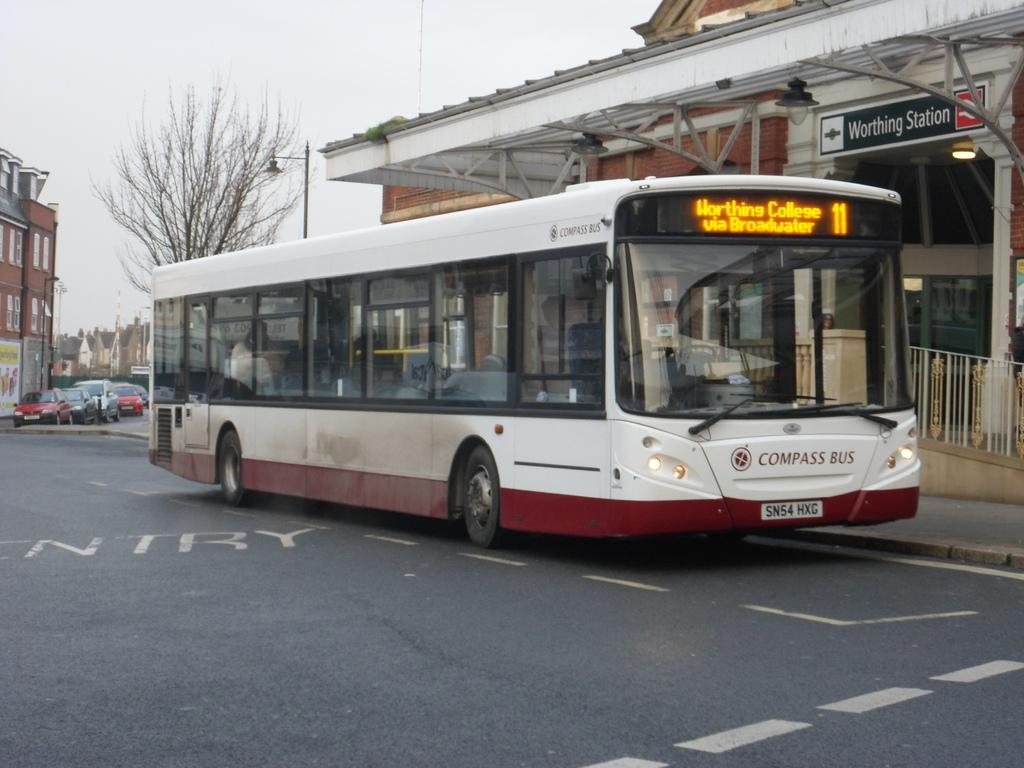<image>
Describe the image concisely. the red and white compass bus is at the station 